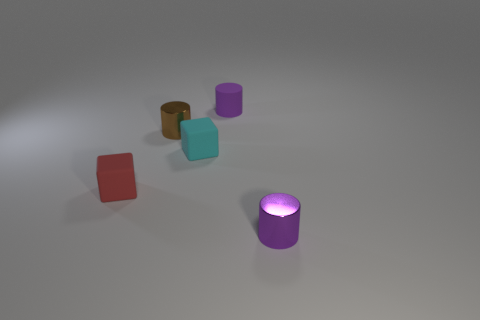Add 1 cubes. How many objects exist? 6 Subtract all cylinders. How many objects are left? 2 Add 2 tiny cyan objects. How many tiny cyan objects are left? 3 Add 5 tiny red objects. How many tiny red objects exist? 6 Subtract 1 brown cylinders. How many objects are left? 4 Subtract all brown shiny objects. Subtract all tiny purple rubber cylinders. How many objects are left? 3 